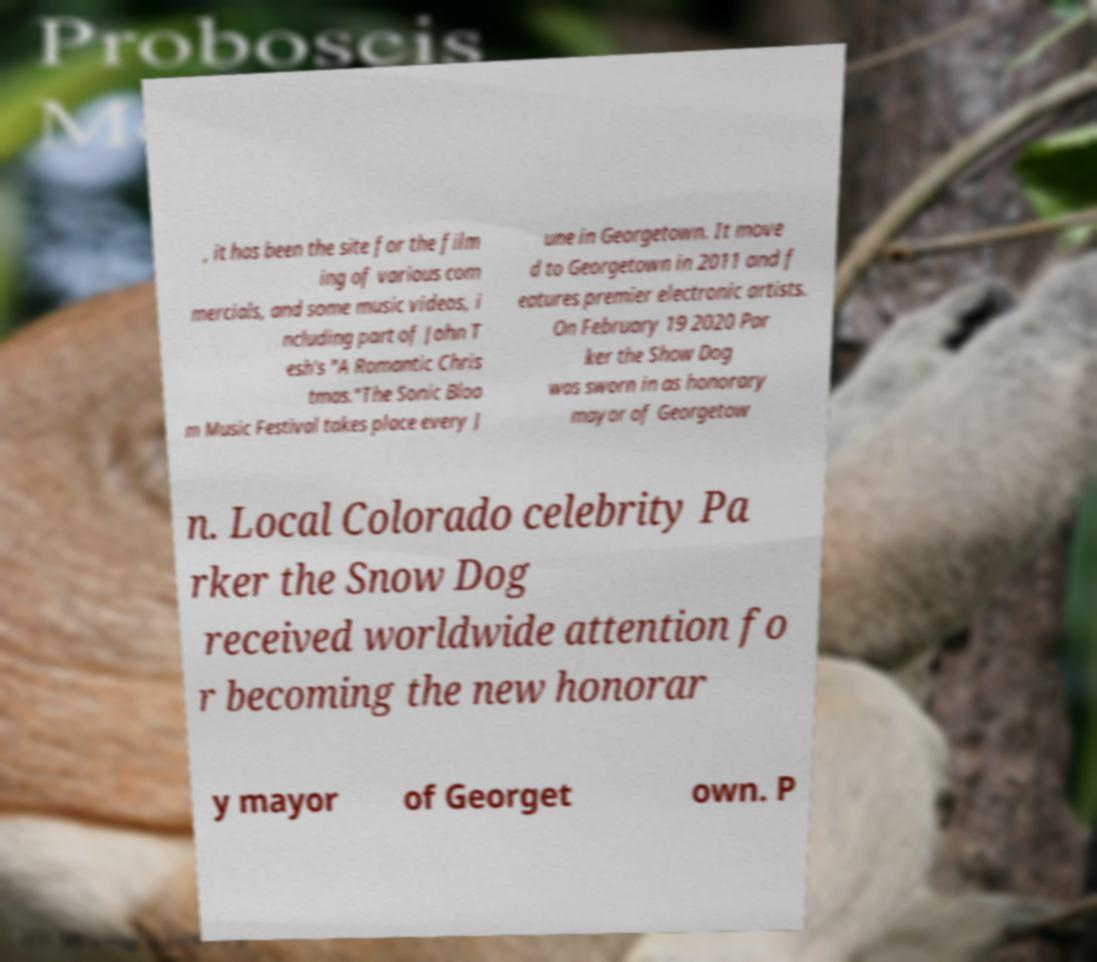I need the written content from this picture converted into text. Can you do that? , it has been the site for the film ing of various com mercials, and some music videos, i ncluding part of John T esh's "A Romantic Chris tmas."The Sonic Bloo m Music Festival takes place every J une in Georgetown. It move d to Georgetown in 2011 and f eatures premier electronic artists. On February 19 2020 Par ker the Show Dog was sworn in as honorary mayor of Georgetow n. Local Colorado celebrity Pa rker the Snow Dog received worldwide attention fo r becoming the new honorar y mayor of Georget own. P 